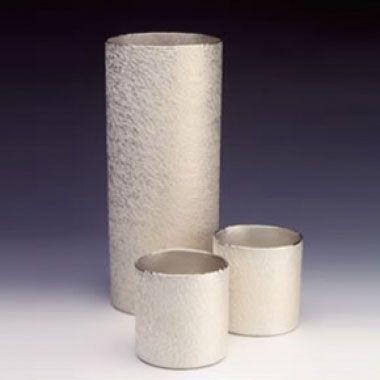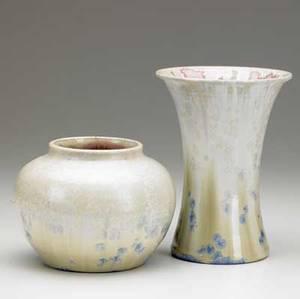The first image is the image on the left, the second image is the image on the right. For the images shown, is this caption "there are no more than 3 vases in an image pair" true? Answer yes or no. No. 